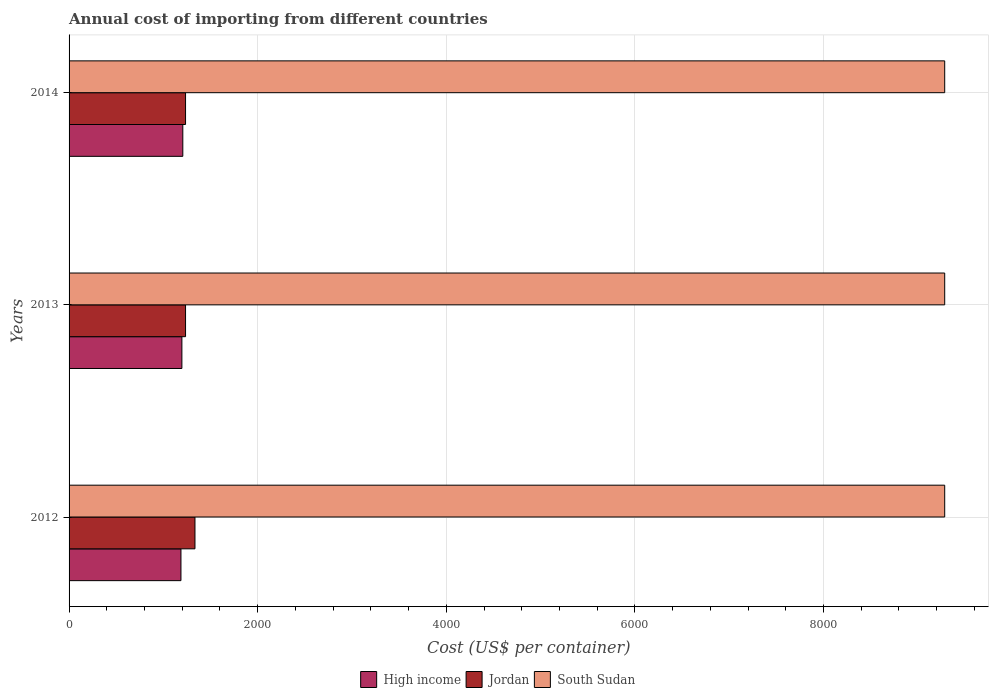What is the total annual cost of importing in South Sudan in 2012?
Your answer should be very brief. 9285. Across all years, what is the maximum total annual cost of importing in Jordan?
Your answer should be compact. 1335. Across all years, what is the minimum total annual cost of importing in High income?
Give a very brief answer. 1186.38. In which year was the total annual cost of importing in Jordan minimum?
Give a very brief answer. 2013. What is the total total annual cost of importing in Jordan in the graph?
Keep it short and to the point. 3805. What is the difference between the total annual cost of importing in High income in 2014 and the total annual cost of importing in Jordan in 2013?
Ensure brevity in your answer.  -28.9. What is the average total annual cost of importing in High income per year?
Offer a very short reply. 1196.29. In the year 2012, what is the difference between the total annual cost of importing in High income and total annual cost of importing in South Sudan?
Your answer should be very brief. -8098.62. In how many years, is the total annual cost of importing in Jordan greater than 7600 US$?
Make the answer very short. 0. What is the ratio of the total annual cost of importing in South Sudan in 2012 to that in 2013?
Offer a very short reply. 1. Is the total annual cost of importing in Jordan in 2012 less than that in 2013?
Your response must be concise. No. Is the difference between the total annual cost of importing in High income in 2012 and 2013 greater than the difference between the total annual cost of importing in South Sudan in 2012 and 2013?
Keep it short and to the point. No. What is the difference between the highest and the lowest total annual cost of importing in High income?
Your answer should be compact. 19.71. Is the sum of the total annual cost of importing in High income in 2012 and 2013 greater than the maximum total annual cost of importing in South Sudan across all years?
Give a very brief answer. No. What does the 3rd bar from the top in 2012 represents?
Your answer should be very brief. High income. What does the 1st bar from the bottom in 2014 represents?
Ensure brevity in your answer.  High income. Is it the case that in every year, the sum of the total annual cost of importing in High income and total annual cost of importing in Jordan is greater than the total annual cost of importing in South Sudan?
Offer a very short reply. No. What is the difference between two consecutive major ticks on the X-axis?
Keep it short and to the point. 2000. Does the graph contain any zero values?
Offer a terse response. No. Does the graph contain grids?
Your answer should be compact. Yes. Where does the legend appear in the graph?
Your answer should be compact. Bottom center. How many legend labels are there?
Ensure brevity in your answer.  3. How are the legend labels stacked?
Make the answer very short. Horizontal. What is the title of the graph?
Provide a short and direct response. Annual cost of importing from different countries. Does "Least developed countries" appear as one of the legend labels in the graph?
Your answer should be compact. No. What is the label or title of the X-axis?
Ensure brevity in your answer.  Cost (US$ per container). What is the label or title of the Y-axis?
Offer a very short reply. Years. What is the Cost (US$ per container) of High income in 2012?
Ensure brevity in your answer.  1186.38. What is the Cost (US$ per container) of Jordan in 2012?
Your answer should be compact. 1335. What is the Cost (US$ per container) of South Sudan in 2012?
Offer a terse response. 9285. What is the Cost (US$ per container) in High income in 2013?
Ensure brevity in your answer.  1196.38. What is the Cost (US$ per container) of Jordan in 2013?
Offer a very short reply. 1235. What is the Cost (US$ per container) in South Sudan in 2013?
Give a very brief answer. 9285. What is the Cost (US$ per container) of High income in 2014?
Offer a very short reply. 1206.1. What is the Cost (US$ per container) in Jordan in 2014?
Your answer should be compact. 1235. What is the Cost (US$ per container) of South Sudan in 2014?
Offer a very short reply. 9285. Across all years, what is the maximum Cost (US$ per container) of High income?
Provide a short and direct response. 1206.1. Across all years, what is the maximum Cost (US$ per container) of Jordan?
Give a very brief answer. 1335. Across all years, what is the maximum Cost (US$ per container) in South Sudan?
Offer a terse response. 9285. Across all years, what is the minimum Cost (US$ per container) in High income?
Ensure brevity in your answer.  1186.38. Across all years, what is the minimum Cost (US$ per container) in Jordan?
Make the answer very short. 1235. Across all years, what is the minimum Cost (US$ per container) of South Sudan?
Offer a very short reply. 9285. What is the total Cost (US$ per container) of High income in the graph?
Your answer should be compact. 3588.86. What is the total Cost (US$ per container) in Jordan in the graph?
Provide a short and direct response. 3805. What is the total Cost (US$ per container) in South Sudan in the graph?
Provide a succinct answer. 2.79e+04. What is the difference between the Cost (US$ per container) in High income in 2012 and that in 2013?
Offer a very short reply. -10. What is the difference between the Cost (US$ per container) in Jordan in 2012 and that in 2013?
Your answer should be very brief. 100. What is the difference between the Cost (US$ per container) in High income in 2012 and that in 2014?
Your answer should be very brief. -19.71. What is the difference between the Cost (US$ per container) in High income in 2013 and that in 2014?
Give a very brief answer. -9.72. What is the difference between the Cost (US$ per container) of Jordan in 2013 and that in 2014?
Offer a terse response. 0. What is the difference between the Cost (US$ per container) of South Sudan in 2013 and that in 2014?
Ensure brevity in your answer.  0. What is the difference between the Cost (US$ per container) of High income in 2012 and the Cost (US$ per container) of Jordan in 2013?
Offer a terse response. -48.62. What is the difference between the Cost (US$ per container) in High income in 2012 and the Cost (US$ per container) in South Sudan in 2013?
Give a very brief answer. -8098.62. What is the difference between the Cost (US$ per container) in Jordan in 2012 and the Cost (US$ per container) in South Sudan in 2013?
Your answer should be compact. -7950. What is the difference between the Cost (US$ per container) in High income in 2012 and the Cost (US$ per container) in Jordan in 2014?
Give a very brief answer. -48.62. What is the difference between the Cost (US$ per container) in High income in 2012 and the Cost (US$ per container) in South Sudan in 2014?
Your answer should be compact. -8098.62. What is the difference between the Cost (US$ per container) of Jordan in 2012 and the Cost (US$ per container) of South Sudan in 2014?
Your answer should be very brief. -7950. What is the difference between the Cost (US$ per container) of High income in 2013 and the Cost (US$ per container) of Jordan in 2014?
Provide a succinct answer. -38.62. What is the difference between the Cost (US$ per container) of High income in 2013 and the Cost (US$ per container) of South Sudan in 2014?
Provide a short and direct response. -8088.62. What is the difference between the Cost (US$ per container) of Jordan in 2013 and the Cost (US$ per container) of South Sudan in 2014?
Ensure brevity in your answer.  -8050. What is the average Cost (US$ per container) of High income per year?
Provide a succinct answer. 1196.29. What is the average Cost (US$ per container) in Jordan per year?
Your answer should be very brief. 1268.33. What is the average Cost (US$ per container) in South Sudan per year?
Provide a succinct answer. 9285. In the year 2012, what is the difference between the Cost (US$ per container) in High income and Cost (US$ per container) in Jordan?
Provide a short and direct response. -148.62. In the year 2012, what is the difference between the Cost (US$ per container) in High income and Cost (US$ per container) in South Sudan?
Keep it short and to the point. -8098.62. In the year 2012, what is the difference between the Cost (US$ per container) in Jordan and Cost (US$ per container) in South Sudan?
Your answer should be very brief. -7950. In the year 2013, what is the difference between the Cost (US$ per container) of High income and Cost (US$ per container) of Jordan?
Provide a short and direct response. -38.62. In the year 2013, what is the difference between the Cost (US$ per container) of High income and Cost (US$ per container) of South Sudan?
Give a very brief answer. -8088.62. In the year 2013, what is the difference between the Cost (US$ per container) in Jordan and Cost (US$ per container) in South Sudan?
Keep it short and to the point. -8050. In the year 2014, what is the difference between the Cost (US$ per container) in High income and Cost (US$ per container) in Jordan?
Ensure brevity in your answer.  -28.9. In the year 2014, what is the difference between the Cost (US$ per container) of High income and Cost (US$ per container) of South Sudan?
Ensure brevity in your answer.  -8078.9. In the year 2014, what is the difference between the Cost (US$ per container) in Jordan and Cost (US$ per container) in South Sudan?
Provide a succinct answer. -8050. What is the ratio of the Cost (US$ per container) in High income in 2012 to that in 2013?
Make the answer very short. 0.99. What is the ratio of the Cost (US$ per container) in Jordan in 2012 to that in 2013?
Provide a succinct answer. 1.08. What is the ratio of the Cost (US$ per container) of High income in 2012 to that in 2014?
Offer a very short reply. 0.98. What is the ratio of the Cost (US$ per container) of Jordan in 2012 to that in 2014?
Your answer should be compact. 1.08. What is the ratio of the Cost (US$ per container) in South Sudan in 2012 to that in 2014?
Offer a terse response. 1. What is the ratio of the Cost (US$ per container) of High income in 2013 to that in 2014?
Your answer should be very brief. 0.99. What is the difference between the highest and the second highest Cost (US$ per container) in High income?
Make the answer very short. 9.72. What is the difference between the highest and the second highest Cost (US$ per container) of South Sudan?
Offer a terse response. 0. What is the difference between the highest and the lowest Cost (US$ per container) of High income?
Keep it short and to the point. 19.71. 